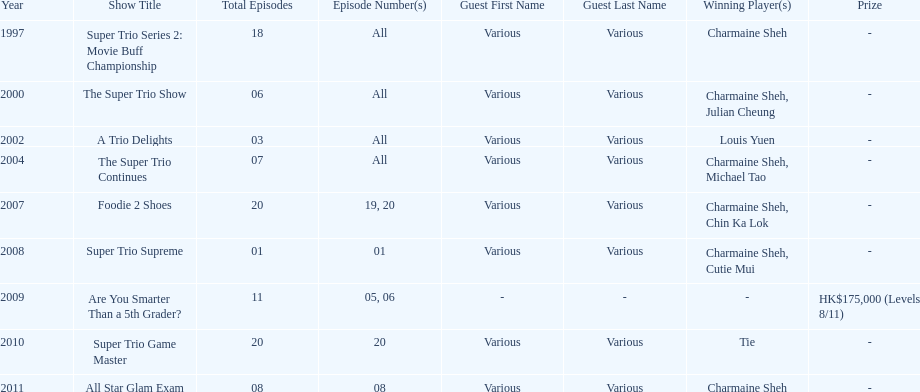What is the number of other guests in the 2002 show "a trio delights"? 5. 